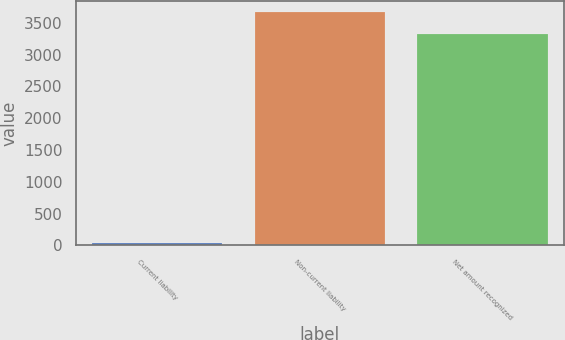<chart> <loc_0><loc_0><loc_500><loc_500><bar_chart><fcel>Current liability<fcel>Non-current liability<fcel>Net amount recognized<nl><fcel>37<fcel>3664<fcel>3329<nl></chart> 